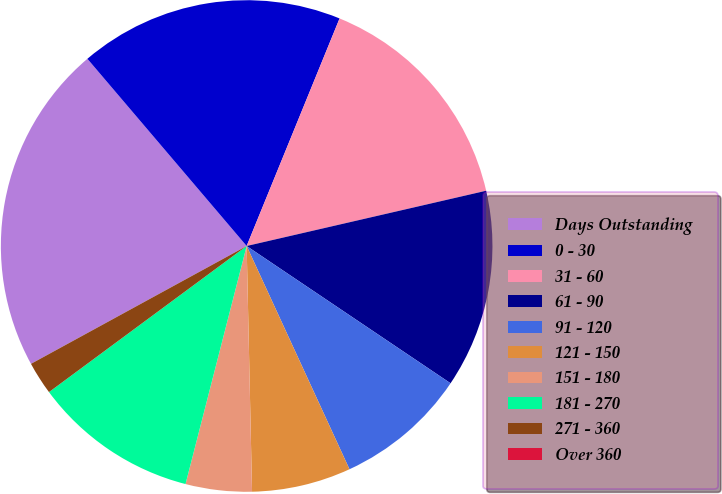<chart> <loc_0><loc_0><loc_500><loc_500><pie_chart><fcel>Days Outstanding<fcel>0 - 30<fcel>31 - 60<fcel>61 - 90<fcel>91 - 120<fcel>121 - 150<fcel>151 - 180<fcel>181 - 270<fcel>271 - 360<fcel>Over 360<nl><fcel>21.74%<fcel>17.39%<fcel>15.22%<fcel>13.04%<fcel>8.7%<fcel>6.52%<fcel>4.35%<fcel>10.87%<fcel>2.17%<fcel>0.0%<nl></chart> 